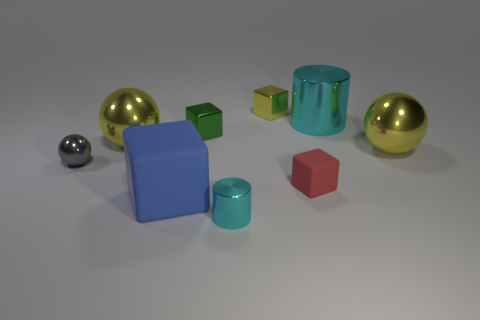Subtract all blocks. How many objects are left? 5 Add 6 tiny red matte blocks. How many tiny red matte blocks exist? 7 Subtract 2 cyan cylinders. How many objects are left? 7 Subtract all small green cubes. Subtract all small cyan metallic cylinders. How many objects are left? 7 Add 7 small yellow blocks. How many small yellow blocks are left? 8 